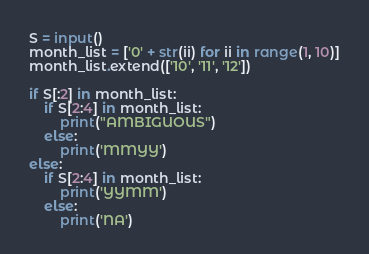Convert code to text. <code><loc_0><loc_0><loc_500><loc_500><_Python_>S = input()
month_list = ['0' + str(ii) for ii in range(1, 10)]
month_list.extend(['10', '11', '12'])

if S[:2] in month_list:
    if S[2:4] in month_list:
        print("AMBIGUOUS")
    else:
        print('MMYY')
else:
    if S[2:4] in month_list:
        print('YYMM')
    else:
        print('NA')</code> 